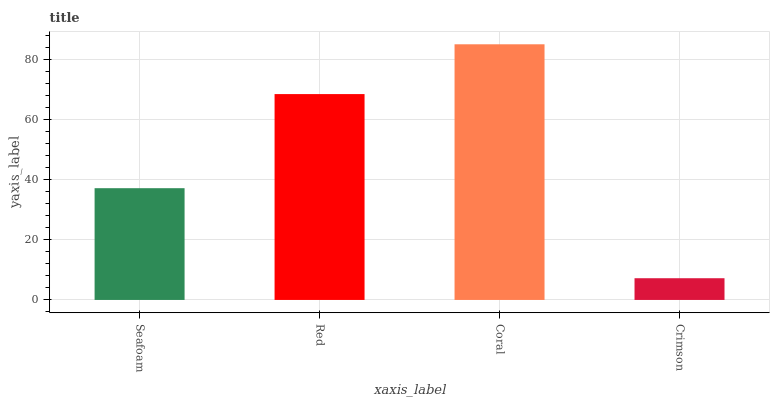Is Crimson the minimum?
Answer yes or no. Yes. Is Coral the maximum?
Answer yes or no. Yes. Is Red the minimum?
Answer yes or no. No. Is Red the maximum?
Answer yes or no. No. Is Red greater than Seafoam?
Answer yes or no. Yes. Is Seafoam less than Red?
Answer yes or no. Yes. Is Seafoam greater than Red?
Answer yes or no. No. Is Red less than Seafoam?
Answer yes or no. No. Is Red the high median?
Answer yes or no. Yes. Is Seafoam the low median?
Answer yes or no. Yes. Is Seafoam the high median?
Answer yes or no. No. Is Coral the low median?
Answer yes or no. No. 